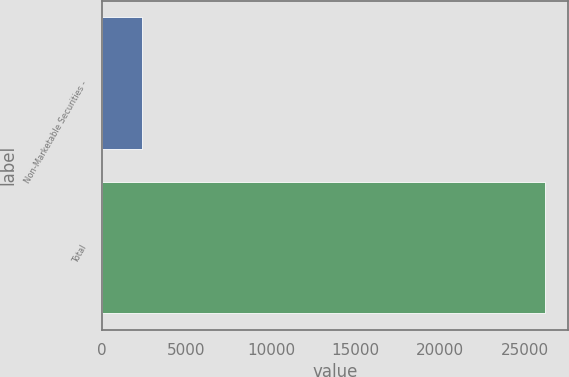Convert chart. <chart><loc_0><loc_0><loc_500><loc_500><bar_chart><fcel>Non-Marketable Securities -<fcel>Total<nl><fcel>2368<fcel>26238.3<nl></chart> 